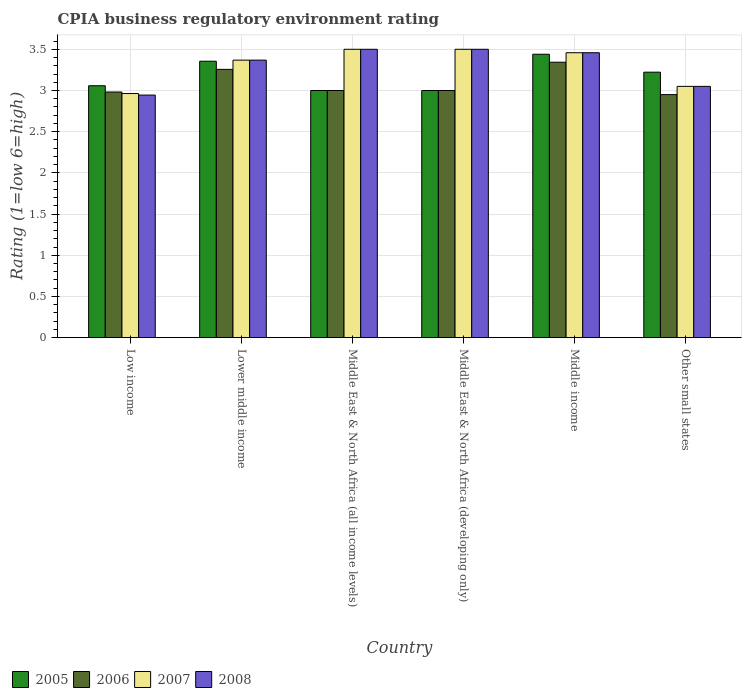How many bars are there on the 2nd tick from the left?
Make the answer very short. 4. What is the label of the 2nd group of bars from the left?
Offer a terse response. Lower middle income. What is the CPIA rating in 2007 in Low income?
Offer a very short reply. 2.96. Across all countries, what is the maximum CPIA rating in 2005?
Provide a succinct answer. 3.44. Across all countries, what is the minimum CPIA rating in 2008?
Offer a very short reply. 2.94. In which country was the CPIA rating in 2008 maximum?
Your answer should be compact. Middle East & North Africa (all income levels). What is the total CPIA rating in 2008 in the graph?
Offer a terse response. 19.82. What is the difference between the CPIA rating in 2008 in Lower middle income and that in Other small states?
Provide a short and direct response. 0.32. What is the difference between the CPIA rating in 2005 in Lower middle income and the CPIA rating in 2006 in Middle East & North Africa (developing only)?
Your answer should be compact. 0.36. What is the average CPIA rating in 2007 per country?
Ensure brevity in your answer.  3.31. What is the difference between the CPIA rating of/in 2007 and CPIA rating of/in 2008 in Other small states?
Your response must be concise. 0. What is the ratio of the CPIA rating in 2005 in Middle East & North Africa (all income levels) to that in Middle East & North Africa (developing only)?
Offer a terse response. 1. Is the CPIA rating in 2006 in Low income less than that in Middle East & North Africa (developing only)?
Make the answer very short. Yes. Is the difference between the CPIA rating in 2007 in Lower middle income and Other small states greater than the difference between the CPIA rating in 2008 in Lower middle income and Other small states?
Your response must be concise. No. What is the difference between the highest and the second highest CPIA rating in 2006?
Your answer should be very brief. 0.26. What is the difference between the highest and the lowest CPIA rating in 2008?
Keep it short and to the point. 0.56. How many bars are there?
Your response must be concise. 24. Does the graph contain any zero values?
Your response must be concise. No. Does the graph contain grids?
Provide a short and direct response. Yes. How are the legend labels stacked?
Offer a very short reply. Horizontal. What is the title of the graph?
Offer a terse response. CPIA business regulatory environment rating. What is the label or title of the X-axis?
Your answer should be very brief. Country. What is the label or title of the Y-axis?
Offer a terse response. Rating (1=low 6=high). What is the Rating (1=low 6=high) of 2005 in Low income?
Your response must be concise. 3.06. What is the Rating (1=low 6=high) of 2006 in Low income?
Your answer should be compact. 2.98. What is the Rating (1=low 6=high) in 2007 in Low income?
Your answer should be very brief. 2.96. What is the Rating (1=low 6=high) in 2008 in Low income?
Ensure brevity in your answer.  2.94. What is the Rating (1=low 6=high) of 2005 in Lower middle income?
Offer a terse response. 3.36. What is the Rating (1=low 6=high) in 2006 in Lower middle income?
Provide a succinct answer. 3.26. What is the Rating (1=low 6=high) in 2007 in Lower middle income?
Give a very brief answer. 3.37. What is the Rating (1=low 6=high) in 2008 in Lower middle income?
Your response must be concise. 3.37. What is the Rating (1=low 6=high) of 2006 in Middle East & North Africa (all income levels)?
Your answer should be very brief. 3. What is the Rating (1=low 6=high) in 2007 in Middle East & North Africa (all income levels)?
Provide a short and direct response. 3.5. What is the Rating (1=low 6=high) in 2006 in Middle East & North Africa (developing only)?
Offer a terse response. 3. What is the Rating (1=low 6=high) in 2008 in Middle East & North Africa (developing only)?
Offer a very short reply. 3.5. What is the Rating (1=low 6=high) in 2005 in Middle income?
Your response must be concise. 3.44. What is the Rating (1=low 6=high) in 2006 in Middle income?
Your response must be concise. 3.34. What is the Rating (1=low 6=high) in 2007 in Middle income?
Offer a terse response. 3.46. What is the Rating (1=low 6=high) in 2008 in Middle income?
Give a very brief answer. 3.46. What is the Rating (1=low 6=high) of 2005 in Other small states?
Provide a short and direct response. 3.22. What is the Rating (1=low 6=high) of 2006 in Other small states?
Your answer should be compact. 2.95. What is the Rating (1=low 6=high) of 2007 in Other small states?
Provide a short and direct response. 3.05. What is the Rating (1=low 6=high) in 2008 in Other small states?
Your response must be concise. 3.05. Across all countries, what is the maximum Rating (1=low 6=high) in 2005?
Your answer should be compact. 3.44. Across all countries, what is the maximum Rating (1=low 6=high) of 2006?
Offer a very short reply. 3.34. Across all countries, what is the minimum Rating (1=low 6=high) of 2006?
Your response must be concise. 2.95. Across all countries, what is the minimum Rating (1=low 6=high) in 2007?
Make the answer very short. 2.96. Across all countries, what is the minimum Rating (1=low 6=high) of 2008?
Keep it short and to the point. 2.94. What is the total Rating (1=low 6=high) of 2005 in the graph?
Offer a terse response. 19.08. What is the total Rating (1=low 6=high) in 2006 in the graph?
Your response must be concise. 18.53. What is the total Rating (1=low 6=high) of 2007 in the graph?
Make the answer very short. 19.84. What is the total Rating (1=low 6=high) of 2008 in the graph?
Offer a terse response. 19.82. What is the difference between the Rating (1=low 6=high) in 2005 in Low income and that in Lower middle income?
Give a very brief answer. -0.3. What is the difference between the Rating (1=low 6=high) in 2006 in Low income and that in Lower middle income?
Offer a very short reply. -0.27. What is the difference between the Rating (1=low 6=high) in 2007 in Low income and that in Lower middle income?
Give a very brief answer. -0.41. What is the difference between the Rating (1=low 6=high) in 2008 in Low income and that in Lower middle income?
Your response must be concise. -0.42. What is the difference between the Rating (1=low 6=high) in 2005 in Low income and that in Middle East & North Africa (all income levels)?
Your response must be concise. 0.06. What is the difference between the Rating (1=low 6=high) of 2006 in Low income and that in Middle East & North Africa (all income levels)?
Offer a terse response. -0.02. What is the difference between the Rating (1=low 6=high) in 2007 in Low income and that in Middle East & North Africa (all income levels)?
Offer a very short reply. -0.54. What is the difference between the Rating (1=low 6=high) of 2008 in Low income and that in Middle East & North Africa (all income levels)?
Ensure brevity in your answer.  -0.56. What is the difference between the Rating (1=low 6=high) of 2005 in Low income and that in Middle East & North Africa (developing only)?
Keep it short and to the point. 0.06. What is the difference between the Rating (1=low 6=high) in 2006 in Low income and that in Middle East & North Africa (developing only)?
Your answer should be compact. -0.02. What is the difference between the Rating (1=low 6=high) of 2007 in Low income and that in Middle East & North Africa (developing only)?
Keep it short and to the point. -0.54. What is the difference between the Rating (1=low 6=high) of 2008 in Low income and that in Middle East & North Africa (developing only)?
Offer a terse response. -0.56. What is the difference between the Rating (1=low 6=high) of 2005 in Low income and that in Middle income?
Provide a short and direct response. -0.38. What is the difference between the Rating (1=low 6=high) of 2006 in Low income and that in Middle income?
Offer a terse response. -0.36. What is the difference between the Rating (1=low 6=high) in 2007 in Low income and that in Middle income?
Offer a very short reply. -0.5. What is the difference between the Rating (1=low 6=high) in 2008 in Low income and that in Middle income?
Provide a succinct answer. -0.51. What is the difference between the Rating (1=low 6=high) in 2005 in Low income and that in Other small states?
Offer a terse response. -0.16. What is the difference between the Rating (1=low 6=high) in 2006 in Low income and that in Other small states?
Keep it short and to the point. 0.03. What is the difference between the Rating (1=low 6=high) of 2007 in Low income and that in Other small states?
Keep it short and to the point. -0.09. What is the difference between the Rating (1=low 6=high) of 2008 in Low income and that in Other small states?
Provide a short and direct response. -0.11. What is the difference between the Rating (1=low 6=high) in 2005 in Lower middle income and that in Middle East & North Africa (all income levels)?
Your response must be concise. 0.36. What is the difference between the Rating (1=low 6=high) in 2006 in Lower middle income and that in Middle East & North Africa (all income levels)?
Ensure brevity in your answer.  0.26. What is the difference between the Rating (1=low 6=high) of 2007 in Lower middle income and that in Middle East & North Africa (all income levels)?
Offer a terse response. -0.13. What is the difference between the Rating (1=low 6=high) of 2008 in Lower middle income and that in Middle East & North Africa (all income levels)?
Give a very brief answer. -0.13. What is the difference between the Rating (1=low 6=high) in 2005 in Lower middle income and that in Middle East & North Africa (developing only)?
Ensure brevity in your answer.  0.36. What is the difference between the Rating (1=low 6=high) of 2006 in Lower middle income and that in Middle East & North Africa (developing only)?
Provide a succinct answer. 0.26. What is the difference between the Rating (1=low 6=high) in 2007 in Lower middle income and that in Middle East & North Africa (developing only)?
Provide a succinct answer. -0.13. What is the difference between the Rating (1=low 6=high) in 2008 in Lower middle income and that in Middle East & North Africa (developing only)?
Provide a succinct answer. -0.13. What is the difference between the Rating (1=low 6=high) in 2005 in Lower middle income and that in Middle income?
Ensure brevity in your answer.  -0.08. What is the difference between the Rating (1=low 6=high) of 2006 in Lower middle income and that in Middle income?
Make the answer very short. -0.09. What is the difference between the Rating (1=low 6=high) in 2007 in Lower middle income and that in Middle income?
Offer a terse response. -0.09. What is the difference between the Rating (1=low 6=high) in 2008 in Lower middle income and that in Middle income?
Offer a very short reply. -0.09. What is the difference between the Rating (1=low 6=high) of 2005 in Lower middle income and that in Other small states?
Your answer should be very brief. 0.13. What is the difference between the Rating (1=low 6=high) in 2006 in Lower middle income and that in Other small states?
Make the answer very short. 0.31. What is the difference between the Rating (1=low 6=high) of 2007 in Lower middle income and that in Other small states?
Make the answer very short. 0.32. What is the difference between the Rating (1=low 6=high) of 2008 in Lower middle income and that in Other small states?
Your response must be concise. 0.32. What is the difference between the Rating (1=low 6=high) in 2006 in Middle East & North Africa (all income levels) and that in Middle East & North Africa (developing only)?
Provide a short and direct response. 0. What is the difference between the Rating (1=low 6=high) of 2007 in Middle East & North Africa (all income levels) and that in Middle East & North Africa (developing only)?
Your answer should be very brief. 0. What is the difference between the Rating (1=low 6=high) in 2008 in Middle East & North Africa (all income levels) and that in Middle East & North Africa (developing only)?
Offer a terse response. 0. What is the difference between the Rating (1=low 6=high) in 2005 in Middle East & North Africa (all income levels) and that in Middle income?
Make the answer very short. -0.44. What is the difference between the Rating (1=low 6=high) in 2006 in Middle East & North Africa (all income levels) and that in Middle income?
Keep it short and to the point. -0.34. What is the difference between the Rating (1=low 6=high) in 2007 in Middle East & North Africa (all income levels) and that in Middle income?
Provide a succinct answer. 0.04. What is the difference between the Rating (1=low 6=high) of 2008 in Middle East & North Africa (all income levels) and that in Middle income?
Offer a very short reply. 0.04. What is the difference between the Rating (1=low 6=high) in 2005 in Middle East & North Africa (all income levels) and that in Other small states?
Keep it short and to the point. -0.22. What is the difference between the Rating (1=low 6=high) in 2006 in Middle East & North Africa (all income levels) and that in Other small states?
Ensure brevity in your answer.  0.05. What is the difference between the Rating (1=low 6=high) in 2007 in Middle East & North Africa (all income levels) and that in Other small states?
Offer a terse response. 0.45. What is the difference between the Rating (1=low 6=high) in 2008 in Middle East & North Africa (all income levels) and that in Other small states?
Your answer should be compact. 0.45. What is the difference between the Rating (1=low 6=high) in 2005 in Middle East & North Africa (developing only) and that in Middle income?
Keep it short and to the point. -0.44. What is the difference between the Rating (1=low 6=high) of 2006 in Middle East & North Africa (developing only) and that in Middle income?
Ensure brevity in your answer.  -0.34. What is the difference between the Rating (1=low 6=high) of 2007 in Middle East & North Africa (developing only) and that in Middle income?
Make the answer very short. 0.04. What is the difference between the Rating (1=low 6=high) of 2008 in Middle East & North Africa (developing only) and that in Middle income?
Make the answer very short. 0.04. What is the difference between the Rating (1=low 6=high) of 2005 in Middle East & North Africa (developing only) and that in Other small states?
Keep it short and to the point. -0.22. What is the difference between the Rating (1=low 6=high) of 2007 in Middle East & North Africa (developing only) and that in Other small states?
Ensure brevity in your answer.  0.45. What is the difference between the Rating (1=low 6=high) of 2008 in Middle East & North Africa (developing only) and that in Other small states?
Your answer should be very brief. 0.45. What is the difference between the Rating (1=low 6=high) of 2005 in Middle income and that in Other small states?
Make the answer very short. 0.22. What is the difference between the Rating (1=low 6=high) of 2006 in Middle income and that in Other small states?
Ensure brevity in your answer.  0.39. What is the difference between the Rating (1=low 6=high) in 2007 in Middle income and that in Other small states?
Provide a succinct answer. 0.41. What is the difference between the Rating (1=low 6=high) in 2008 in Middle income and that in Other small states?
Your answer should be very brief. 0.41. What is the difference between the Rating (1=low 6=high) of 2005 in Low income and the Rating (1=low 6=high) of 2006 in Lower middle income?
Keep it short and to the point. -0.2. What is the difference between the Rating (1=low 6=high) of 2005 in Low income and the Rating (1=low 6=high) of 2007 in Lower middle income?
Your response must be concise. -0.31. What is the difference between the Rating (1=low 6=high) of 2005 in Low income and the Rating (1=low 6=high) of 2008 in Lower middle income?
Keep it short and to the point. -0.31. What is the difference between the Rating (1=low 6=high) of 2006 in Low income and the Rating (1=low 6=high) of 2007 in Lower middle income?
Provide a succinct answer. -0.39. What is the difference between the Rating (1=low 6=high) of 2006 in Low income and the Rating (1=low 6=high) of 2008 in Lower middle income?
Provide a succinct answer. -0.39. What is the difference between the Rating (1=low 6=high) in 2007 in Low income and the Rating (1=low 6=high) in 2008 in Lower middle income?
Your answer should be compact. -0.41. What is the difference between the Rating (1=low 6=high) of 2005 in Low income and the Rating (1=low 6=high) of 2006 in Middle East & North Africa (all income levels)?
Your answer should be very brief. 0.06. What is the difference between the Rating (1=low 6=high) of 2005 in Low income and the Rating (1=low 6=high) of 2007 in Middle East & North Africa (all income levels)?
Make the answer very short. -0.44. What is the difference between the Rating (1=low 6=high) in 2005 in Low income and the Rating (1=low 6=high) in 2008 in Middle East & North Africa (all income levels)?
Offer a very short reply. -0.44. What is the difference between the Rating (1=low 6=high) of 2006 in Low income and the Rating (1=low 6=high) of 2007 in Middle East & North Africa (all income levels)?
Provide a short and direct response. -0.52. What is the difference between the Rating (1=low 6=high) of 2006 in Low income and the Rating (1=low 6=high) of 2008 in Middle East & North Africa (all income levels)?
Your answer should be compact. -0.52. What is the difference between the Rating (1=low 6=high) of 2007 in Low income and the Rating (1=low 6=high) of 2008 in Middle East & North Africa (all income levels)?
Make the answer very short. -0.54. What is the difference between the Rating (1=low 6=high) of 2005 in Low income and the Rating (1=low 6=high) of 2006 in Middle East & North Africa (developing only)?
Provide a succinct answer. 0.06. What is the difference between the Rating (1=low 6=high) in 2005 in Low income and the Rating (1=low 6=high) in 2007 in Middle East & North Africa (developing only)?
Keep it short and to the point. -0.44. What is the difference between the Rating (1=low 6=high) of 2005 in Low income and the Rating (1=low 6=high) of 2008 in Middle East & North Africa (developing only)?
Offer a terse response. -0.44. What is the difference between the Rating (1=low 6=high) in 2006 in Low income and the Rating (1=low 6=high) in 2007 in Middle East & North Africa (developing only)?
Your answer should be compact. -0.52. What is the difference between the Rating (1=low 6=high) of 2006 in Low income and the Rating (1=low 6=high) of 2008 in Middle East & North Africa (developing only)?
Make the answer very short. -0.52. What is the difference between the Rating (1=low 6=high) of 2007 in Low income and the Rating (1=low 6=high) of 2008 in Middle East & North Africa (developing only)?
Your response must be concise. -0.54. What is the difference between the Rating (1=low 6=high) in 2005 in Low income and the Rating (1=low 6=high) in 2006 in Middle income?
Give a very brief answer. -0.29. What is the difference between the Rating (1=low 6=high) in 2005 in Low income and the Rating (1=low 6=high) in 2007 in Middle income?
Offer a terse response. -0.4. What is the difference between the Rating (1=low 6=high) in 2005 in Low income and the Rating (1=low 6=high) in 2008 in Middle income?
Your answer should be very brief. -0.4. What is the difference between the Rating (1=low 6=high) in 2006 in Low income and the Rating (1=low 6=high) in 2007 in Middle income?
Your answer should be compact. -0.48. What is the difference between the Rating (1=low 6=high) in 2006 in Low income and the Rating (1=low 6=high) in 2008 in Middle income?
Keep it short and to the point. -0.48. What is the difference between the Rating (1=low 6=high) in 2007 in Low income and the Rating (1=low 6=high) in 2008 in Middle income?
Keep it short and to the point. -0.5. What is the difference between the Rating (1=low 6=high) of 2005 in Low income and the Rating (1=low 6=high) of 2006 in Other small states?
Give a very brief answer. 0.11. What is the difference between the Rating (1=low 6=high) in 2005 in Low income and the Rating (1=low 6=high) in 2007 in Other small states?
Offer a terse response. 0.01. What is the difference between the Rating (1=low 6=high) in 2005 in Low income and the Rating (1=low 6=high) in 2008 in Other small states?
Make the answer very short. 0.01. What is the difference between the Rating (1=low 6=high) in 2006 in Low income and the Rating (1=low 6=high) in 2007 in Other small states?
Keep it short and to the point. -0.07. What is the difference between the Rating (1=low 6=high) of 2006 in Low income and the Rating (1=low 6=high) of 2008 in Other small states?
Offer a very short reply. -0.07. What is the difference between the Rating (1=low 6=high) of 2007 in Low income and the Rating (1=low 6=high) of 2008 in Other small states?
Provide a succinct answer. -0.09. What is the difference between the Rating (1=low 6=high) in 2005 in Lower middle income and the Rating (1=low 6=high) in 2006 in Middle East & North Africa (all income levels)?
Offer a very short reply. 0.36. What is the difference between the Rating (1=low 6=high) of 2005 in Lower middle income and the Rating (1=low 6=high) of 2007 in Middle East & North Africa (all income levels)?
Your response must be concise. -0.14. What is the difference between the Rating (1=low 6=high) in 2005 in Lower middle income and the Rating (1=low 6=high) in 2008 in Middle East & North Africa (all income levels)?
Provide a succinct answer. -0.14. What is the difference between the Rating (1=low 6=high) in 2006 in Lower middle income and the Rating (1=low 6=high) in 2007 in Middle East & North Africa (all income levels)?
Keep it short and to the point. -0.24. What is the difference between the Rating (1=low 6=high) in 2006 in Lower middle income and the Rating (1=low 6=high) in 2008 in Middle East & North Africa (all income levels)?
Offer a terse response. -0.24. What is the difference between the Rating (1=low 6=high) in 2007 in Lower middle income and the Rating (1=low 6=high) in 2008 in Middle East & North Africa (all income levels)?
Make the answer very short. -0.13. What is the difference between the Rating (1=low 6=high) of 2005 in Lower middle income and the Rating (1=low 6=high) of 2006 in Middle East & North Africa (developing only)?
Your response must be concise. 0.36. What is the difference between the Rating (1=low 6=high) of 2005 in Lower middle income and the Rating (1=low 6=high) of 2007 in Middle East & North Africa (developing only)?
Your answer should be compact. -0.14. What is the difference between the Rating (1=low 6=high) of 2005 in Lower middle income and the Rating (1=low 6=high) of 2008 in Middle East & North Africa (developing only)?
Your answer should be very brief. -0.14. What is the difference between the Rating (1=low 6=high) of 2006 in Lower middle income and the Rating (1=low 6=high) of 2007 in Middle East & North Africa (developing only)?
Offer a terse response. -0.24. What is the difference between the Rating (1=low 6=high) of 2006 in Lower middle income and the Rating (1=low 6=high) of 2008 in Middle East & North Africa (developing only)?
Your answer should be very brief. -0.24. What is the difference between the Rating (1=low 6=high) of 2007 in Lower middle income and the Rating (1=low 6=high) of 2008 in Middle East & North Africa (developing only)?
Offer a very short reply. -0.13. What is the difference between the Rating (1=low 6=high) of 2005 in Lower middle income and the Rating (1=low 6=high) of 2006 in Middle income?
Provide a short and direct response. 0.01. What is the difference between the Rating (1=low 6=high) in 2005 in Lower middle income and the Rating (1=low 6=high) in 2007 in Middle income?
Your answer should be compact. -0.1. What is the difference between the Rating (1=low 6=high) in 2005 in Lower middle income and the Rating (1=low 6=high) in 2008 in Middle income?
Your answer should be compact. -0.1. What is the difference between the Rating (1=low 6=high) in 2006 in Lower middle income and the Rating (1=low 6=high) in 2007 in Middle income?
Ensure brevity in your answer.  -0.2. What is the difference between the Rating (1=low 6=high) of 2006 in Lower middle income and the Rating (1=low 6=high) of 2008 in Middle income?
Make the answer very short. -0.2. What is the difference between the Rating (1=low 6=high) of 2007 in Lower middle income and the Rating (1=low 6=high) of 2008 in Middle income?
Ensure brevity in your answer.  -0.09. What is the difference between the Rating (1=low 6=high) in 2005 in Lower middle income and the Rating (1=low 6=high) in 2006 in Other small states?
Your answer should be very brief. 0.41. What is the difference between the Rating (1=low 6=high) in 2005 in Lower middle income and the Rating (1=low 6=high) in 2007 in Other small states?
Give a very brief answer. 0.31. What is the difference between the Rating (1=low 6=high) in 2005 in Lower middle income and the Rating (1=low 6=high) in 2008 in Other small states?
Give a very brief answer. 0.31. What is the difference between the Rating (1=low 6=high) in 2006 in Lower middle income and the Rating (1=low 6=high) in 2007 in Other small states?
Keep it short and to the point. 0.21. What is the difference between the Rating (1=low 6=high) in 2006 in Lower middle income and the Rating (1=low 6=high) in 2008 in Other small states?
Ensure brevity in your answer.  0.21. What is the difference between the Rating (1=low 6=high) in 2007 in Lower middle income and the Rating (1=low 6=high) in 2008 in Other small states?
Ensure brevity in your answer.  0.32. What is the difference between the Rating (1=low 6=high) in 2005 in Middle East & North Africa (all income levels) and the Rating (1=low 6=high) in 2006 in Middle East & North Africa (developing only)?
Ensure brevity in your answer.  0. What is the difference between the Rating (1=low 6=high) in 2005 in Middle East & North Africa (all income levels) and the Rating (1=low 6=high) in 2007 in Middle East & North Africa (developing only)?
Keep it short and to the point. -0.5. What is the difference between the Rating (1=low 6=high) of 2005 in Middle East & North Africa (all income levels) and the Rating (1=low 6=high) of 2008 in Middle East & North Africa (developing only)?
Your answer should be very brief. -0.5. What is the difference between the Rating (1=low 6=high) of 2005 in Middle East & North Africa (all income levels) and the Rating (1=low 6=high) of 2006 in Middle income?
Your response must be concise. -0.34. What is the difference between the Rating (1=low 6=high) of 2005 in Middle East & North Africa (all income levels) and the Rating (1=low 6=high) of 2007 in Middle income?
Your response must be concise. -0.46. What is the difference between the Rating (1=low 6=high) in 2005 in Middle East & North Africa (all income levels) and the Rating (1=low 6=high) in 2008 in Middle income?
Offer a very short reply. -0.46. What is the difference between the Rating (1=low 6=high) in 2006 in Middle East & North Africa (all income levels) and the Rating (1=low 6=high) in 2007 in Middle income?
Provide a succinct answer. -0.46. What is the difference between the Rating (1=low 6=high) in 2006 in Middle East & North Africa (all income levels) and the Rating (1=low 6=high) in 2008 in Middle income?
Keep it short and to the point. -0.46. What is the difference between the Rating (1=low 6=high) in 2007 in Middle East & North Africa (all income levels) and the Rating (1=low 6=high) in 2008 in Middle income?
Provide a succinct answer. 0.04. What is the difference between the Rating (1=low 6=high) in 2005 in Middle East & North Africa (all income levels) and the Rating (1=low 6=high) in 2006 in Other small states?
Your answer should be very brief. 0.05. What is the difference between the Rating (1=low 6=high) in 2005 in Middle East & North Africa (all income levels) and the Rating (1=low 6=high) in 2007 in Other small states?
Give a very brief answer. -0.05. What is the difference between the Rating (1=low 6=high) in 2006 in Middle East & North Africa (all income levels) and the Rating (1=low 6=high) in 2007 in Other small states?
Ensure brevity in your answer.  -0.05. What is the difference between the Rating (1=low 6=high) of 2007 in Middle East & North Africa (all income levels) and the Rating (1=low 6=high) of 2008 in Other small states?
Keep it short and to the point. 0.45. What is the difference between the Rating (1=low 6=high) in 2005 in Middle East & North Africa (developing only) and the Rating (1=low 6=high) in 2006 in Middle income?
Keep it short and to the point. -0.34. What is the difference between the Rating (1=low 6=high) in 2005 in Middle East & North Africa (developing only) and the Rating (1=low 6=high) in 2007 in Middle income?
Make the answer very short. -0.46. What is the difference between the Rating (1=low 6=high) of 2005 in Middle East & North Africa (developing only) and the Rating (1=low 6=high) of 2008 in Middle income?
Make the answer very short. -0.46. What is the difference between the Rating (1=low 6=high) of 2006 in Middle East & North Africa (developing only) and the Rating (1=low 6=high) of 2007 in Middle income?
Provide a succinct answer. -0.46. What is the difference between the Rating (1=low 6=high) of 2006 in Middle East & North Africa (developing only) and the Rating (1=low 6=high) of 2008 in Middle income?
Your response must be concise. -0.46. What is the difference between the Rating (1=low 6=high) of 2007 in Middle East & North Africa (developing only) and the Rating (1=low 6=high) of 2008 in Middle income?
Keep it short and to the point. 0.04. What is the difference between the Rating (1=low 6=high) of 2005 in Middle East & North Africa (developing only) and the Rating (1=low 6=high) of 2008 in Other small states?
Keep it short and to the point. -0.05. What is the difference between the Rating (1=low 6=high) in 2006 in Middle East & North Africa (developing only) and the Rating (1=low 6=high) in 2007 in Other small states?
Your answer should be very brief. -0.05. What is the difference between the Rating (1=low 6=high) of 2006 in Middle East & North Africa (developing only) and the Rating (1=low 6=high) of 2008 in Other small states?
Your answer should be compact. -0.05. What is the difference between the Rating (1=low 6=high) of 2007 in Middle East & North Africa (developing only) and the Rating (1=low 6=high) of 2008 in Other small states?
Ensure brevity in your answer.  0.45. What is the difference between the Rating (1=low 6=high) in 2005 in Middle income and the Rating (1=low 6=high) in 2006 in Other small states?
Offer a terse response. 0.49. What is the difference between the Rating (1=low 6=high) of 2005 in Middle income and the Rating (1=low 6=high) of 2007 in Other small states?
Provide a succinct answer. 0.39. What is the difference between the Rating (1=low 6=high) in 2005 in Middle income and the Rating (1=low 6=high) in 2008 in Other small states?
Make the answer very short. 0.39. What is the difference between the Rating (1=low 6=high) in 2006 in Middle income and the Rating (1=low 6=high) in 2007 in Other small states?
Provide a succinct answer. 0.29. What is the difference between the Rating (1=low 6=high) in 2006 in Middle income and the Rating (1=low 6=high) in 2008 in Other small states?
Offer a very short reply. 0.29. What is the difference between the Rating (1=low 6=high) in 2007 in Middle income and the Rating (1=low 6=high) in 2008 in Other small states?
Offer a very short reply. 0.41. What is the average Rating (1=low 6=high) of 2005 per country?
Keep it short and to the point. 3.18. What is the average Rating (1=low 6=high) in 2006 per country?
Your response must be concise. 3.09. What is the average Rating (1=low 6=high) in 2007 per country?
Keep it short and to the point. 3.31. What is the average Rating (1=low 6=high) of 2008 per country?
Provide a succinct answer. 3.3. What is the difference between the Rating (1=low 6=high) of 2005 and Rating (1=low 6=high) of 2006 in Low income?
Provide a short and direct response. 0.08. What is the difference between the Rating (1=low 6=high) of 2005 and Rating (1=low 6=high) of 2007 in Low income?
Your response must be concise. 0.09. What is the difference between the Rating (1=low 6=high) in 2005 and Rating (1=low 6=high) in 2008 in Low income?
Keep it short and to the point. 0.11. What is the difference between the Rating (1=low 6=high) of 2006 and Rating (1=low 6=high) of 2007 in Low income?
Keep it short and to the point. 0.02. What is the difference between the Rating (1=low 6=high) in 2006 and Rating (1=low 6=high) in 2008 in Low income?
Ensure brevity in your answer.  0.04. What is the difference between the Rating (1=low 6=high) in 2007 and Rating (1=low 6=high) in 2008 in Low income?
Offer a very short reply. 0.02. What is the difference between the Rating (1=low 6=high) of 2005 and Rating (1=low 6=high) of 2006 in Lower middle income?
Offer a terse response. 0.1. What is the difference between the Rating (1=low 6=high) of 2005 and Rating (1=low 6=high) of 2007 in Lower middle income?
Keep it short and to the point. -0.01. What is the difference between the Rating (1=low 6=high) in 2005 and Rating (1=low 6=high) in 2008 in Lower middle income?
Give a very brief answer. -0.01. What is the difference between the Rating (1=low 6=high) in 2006 and Rating (1=low 6=high) in 2007 in Lower middle income?
Your answer should be very brief. -0.11. What is the difference between the Rating (1=low 6=high) of 2006 and Rating (1=low 6=high) of 2008 in Lower middle income?
Make the answer very short. -0.11. What is the difference between the Rating (1=low 6=high) of 2007 and Rating (1=low 6=high) of 2008 in Lower middle income?
Give a very brief answer. 0. What is the difference between the Rating (1=low 6=high) in 2005 and Rating (1=low 6=high) in 2006 in Middle East & North Africa (all income levels)?
Offer a very short reply. 0. What is the difference between the Rating (1=low 6=high) of 2005 and Rating (1=low 6=high) of 2007 in Middle East & North Africa (all income levels)?
Make the answer very short. -0.5. What is the difference between the Rating (1=low 6=high) in 2006 and Rating (1=low 6=high) in 2007 in Middle East & North Africa (all income levels)?
Your answer should be compact. -0.5. What is the difference between the Rating (1=low 6=high) in 2007 and Rating (1=low 6=high) in 2008 in Middle East & North Africa (all income levels)?
Your answer should be very brief. 0. What is the difference between the Rating (1=low 6=high) in 2005 and Rating (1=low 6=high) in 2006 in Middle East & North Africa (developing only)?
Your answer should be very brief. 0. What is the difference between the Rating (1=low 6=high) of 2005 and Rating (1=low 6=high) of 2007 in Middle East & North Africa (developing only)?
Your answer should be compact. -0.5. What is the difference between the Rating (1=low 6=high) of 2005 and Rating (1=low 6=high) of 2008 in Middle East & North Africa (developing only)?
Make the answer very short. -0.5. What is the difference between the Rating (1=low 6=high) of 2006 and Rating (1=low 6=high) of 2008 in Middle East & North Africa (developing only)?
Your answer should be very brief. -0.5. What is the difference between the Rating (1=low 6=high) in 2005 and Rating (1=low 6=high) in 2006 in Middle income?
Keep it short and to the point. 0.1. What is the difference between the Rating (1=low 6=high) in 2005 and Rating (1=low 6=high) in 2007 in Middle income?
Ensure brevity in your answer.  -0.02. What is the difference between the Rating (1=low 6=high) in 2005 and Rating (1=low 6=high) in 2008 in Middle income?
Give a very brief answer. -0.02. What is the difference between the Rating (1=low 6=high) of 2006 and Rating (1=low 6=high) of 2007 in Middle income?
Your answer should be compact. -0.12. What is the difference between the Rating (1=low 6=high) in 2006 and Rating (1=low 6=high) in 2008 in Middle income?
Your answer should be compact. -0.12. What is the difference between the Rating (1=low 6=high) in 2007 and Rating (1=low 6=high) in 2008 in Middle income?
Provide a succinct answer. 0. What is the difference between the Rating (1=low 6=high) of 2005 and Rating (1=low 6=high) of 2006 in Other small states?
Make the answer very short. 0.27. What is the difference between the Rating (1=low 6=high) in 2005 and Rating (1=low 6=high) in 2007 in Other small states?
Give a very brief answer. 0.17. What is the difference between the Rating (1=low 6=high) of 2005 and Rating (1=low 6=high) of 2008 in Other small states?
Your response must be concise. 0.17. What is the ratio of the Rating (1=low 6=high) of 2005 in Low income to that in Lower middle income?
Offer a very short reply. 0.91. What is the ratio of the Rating (1=low 6=high) of 2006 in Low income to that in Lower middle income?
Make the answer very short. 0.92. What is the ratio of the Rating (1=low 6=high) in 2007 in Low income to that in Lower middle income?
Provide a succinct answer. 0.88. What is the ratio of the Rating (1=low 6=high) of 2008 in Low income to that in Lower middle income?
Make the answer very short. 0.87. What is the ratio of the Rating (1=low 6=high) in 2005 in Low income to that in Middle East & North Africa (all income levels)?
Ensure brevity in your answer.  1.02. What is the ratio of the Rating (1=low 6=high) of 2007 in Low income to that in Middle East & North Africa (all income levels)?
Your answer should be compact. 0.85. What is the ratio of the Rating (1=low 6=high) of 2008 in Low income to that in Middle East & North Africa (all income levels)?
Offer a terse response. 0.84. What is the ratio of the Rating (1=low 6=high) in 2005 in Low income to that in Middle East & North Africa (developing only)?
Your response must be concise. 1.02. What is the ratio of the Rating (1=low 6=high) in 2007 in Low income to that in Middle East & North Africa (developing only)?
Your answer should be very brief. 0.85. What is the ratio of the Rating (1=low 6=high) of 2008 in Low income to that in Middle East & North Africa (developing only)?
Ensure brevity in your answer.  0.84. What is the ratio of the Rating (1=low 6=high) in 2005 in Low income to that in Middle income?
Your response must be concise. 0.89. What is the ratio of the Rating (1=low 6=high) in 2006 in Low income to that in Middle income?
Make the answer very short. 0.89. What is the ratio of the Rating (1=low 6=high) in 2007 in Low income to that in Middle income?
Provide a short and direct response. 0.86. What is the ratio of the Rating (1=low 6=high) of 2008 in Low income to that in Middle income?
Your response must be concise. 0.85. What is the ratio of the Rating (1=low 6=high) of 2005 in Low income to that in Other small states?
Provide a succinct answer. 0.95. What is the ratio of the Rating (1=low 6=high) in 2006 in Low income to that in Other small states?
Your answer should be compact. 1.01. What is the ratio of the Rating (1=low 6=high) in 2007 in Low income to that in Other small states?
Give a very brief answer. 0.97. What is the ratio of the Rating (1=low 6=high) in 2008 in Low income to that in Other small states?
Ensure brevity in your answer.  0.97. What is the ratio of the Rating (1=low 6=high) of 2005 in Lower middle income to that in Middle East & North Africa (all income levels)?
Offer a very short reply. 1.12. What is the ratio of the Rating (1=low 6=high) of 2006 in Lower middle income to that in Middle East & North Africa (all income levels)?
Offer a very short reply. 1.09. What is the ratio of the Rating (1=low 6=high) in 2007 in Lower middle income to that in Middle East & North Africa (all income levels)?
Your answer should be very brief. 0.96. What is the ratio of the Rating (1=low 6=high) of 2008 in Lower middle income to that in Middle East & North Africa (all income levels)?
Your answer should be compact. 0.96. What is the ratio of the Rating (1=low 6=high) of 2005 in Lower middle income to that in Middle East & North Africa (developing only)?
Offer a very short reply. 1.12. What is the ratio of the Rating (1=low 6=high) of 2006 in Lower middle income to that in Middle East & North Africa (developing only)?
Give a very brief answer. 1.09. What is the ratio of the Rating (1=low 6=high) of 2007 in Lower middle income to that in Middle East & North Africa (developing only)?
Your response must be concise. 0.96. What is the ratio of the Rating (1=low 6=high) of 2008 in Lower middle income to that in Middle East & North Africa (developing only)?
Your answer should be compact. 0.96. What is the ratio of the Rating (1=low 6=high) in 2005 in Lower middle income to that in Middle income?
Your response must be concise. 0.98. What is the ratio of the Rating (1=low 6=high) of 2006 in Lower middle income to that in Middle income?
Your answer should be very brief. 0.97. What is the ratio of the Rating (1=low 6=high) in 2008 in Lower middle income to that in Middle income?
Ensure brevity in your answer.  0.97. What is the ratio of the Rating (1=low 6=high) in 2005 in Lower middle income to that in Other small states?
Provide a succinct answer. 1.04. What is the ratio of the Rating (1=low 6=high) in 2006 in Lower middle income to that in Other small states?
Your answer should be compact. 1.1. What is the ratio of the Rating (1=low 6=high) of 2007 in Lower middle income to that in Other small states?
Provide a short and direct response. 1.1. What is the ratio of the Rating (1=low 6=high) of 2008 in Lower middle income to that in Other small states?
Offer a terse response. 1.1. What is the ratio of the Rating (1=low 6=high) of 2006 in Middle East & North Africa (all income levels) to that in Middle East & North Africa (developing only)?
Keep it short and to the point. 1. What is the ratio of the Rating (1=low 6=high) in 2007 in Middle East & North Africa (all income levels) to that in Middle East & North Africa (developing only)?
Your answer should be very brief. 1. What is the ratio of the Rating (1=low 6=high) in 2008 in Middle East & North Africa (all income levels) to that in Middle East & North Africa (developing only)?
Make the answer very short. 1. What is the ratio of the Rating (1=low 6=high) in 2005 in Middle East & North Africa (all income levels) to that in Middle income?
Offer a terse response. 0.87. What is the ratio of the Rating (1=low 6=high) of 2006 in Middle East & North Africa (all income levels) to that in Middle income?
Your answer should be very brief. 0.9. What is the ratio of the Rating (1=low 6=high) in 2007 in Middle East & North Africa (all income levels) to that in Middle income?
Provide a short and direct response. 1.01. What is the ratio of the Rating (1=low 6=high) of 2005 in Middle East & North Africa (all income levels) to that in Other small states?
Ensure brevity in your answer.  0.93. What is the ratio of the Rating (1=low 6=high) in 2006 in Middle East & North Africa (all income levels) to that in Other small states?
Give a very brief answer. 1.02. What is the ratio of the Rating (1=low 6=high) in 2007 in Middle East & North Africa (all income levels) to that in Other small states?
Provide a succinct answer. 1.15. What is the ratio of the Rating (1=low 6=high) in 2008 in Middle East & North Africa (all income levels) to that in Other small states?
Make the answer very short. 1.15. What is the ratio of the Rating (1=low 6=high) in 2005 in Middle East & North Africa (developing only) to that in Middle income?
Your response must be concise. 0.87. What is the ratio of the Rating (1=low 6=high) in 2006 in Middle East & North Africa (developing only) to that in Middle income?
Offer a terse response. 0.9. What is the ratio of the Rating (1=low 6=high) of 2005 in Middle East & North Africa (developing only) to that in Other small states?
Provide a short and direct response. 0.93. What is the ratio of the Rating (1=low 6=high) in 2006 in Middle East & North Africa (developing only) to that in Other small states?
Your response must be concise. 1.02. What is the ratio of the Rating (1=low 6=high) in 2007 in Middle East & North Africa (developing only) to that in Other small states?
Offer a very short reply. 1.15. What is the ratio of the Rating (1=low 6=high) in 2008 in Middle East & North Africa (developing only) to that in Other small states?
Provide a succinct answer. 1.15. What is the ratio of the Rating (1=low 6=high) of 2005 in Middle income to that in Other small states?
Give a very brief answer. 1.07. What is the ratio of the Rating (1=low 6=high) in 2006 in Middle income to that in Other small states?
Give a very brief answer. 1.13. What is the ratio of the Rating (1=low 6=high) of 2007 in Middle income to that in Other small states?
Keep it short and to the point. 1.13. What is the ratio of the Rating (1=low 6=high) in 2008 in Middle income to that in Other small states?
Ensure brevity in your answer.  1.13. What is the difference between the highest and the second highest Rating (1=low 6=high) in 2005?
Offer a terse response. 0.08. What is the difference between the highest and the second highest Rating (1=low 6=high) of 2006?
Your answer should be very brief. 0.09. What is the difference between the highest and the lowest Rating (1=low 6=high) in 2005?
Provide a short and direct response. 0.44. What is the difference between the highest and the lowest Rating (1=low 6=high) of 2006?
Make the answer very short. 0.39. What is the difference between the highest and the lowest Rating (1=low 6=high) in 2007?
Your answer should be very brief. 0.54. What is the difference between the highest and the lowest Rating (1=low 6=high) in 2008?
Ensure brevity in your answer.  0.56. 